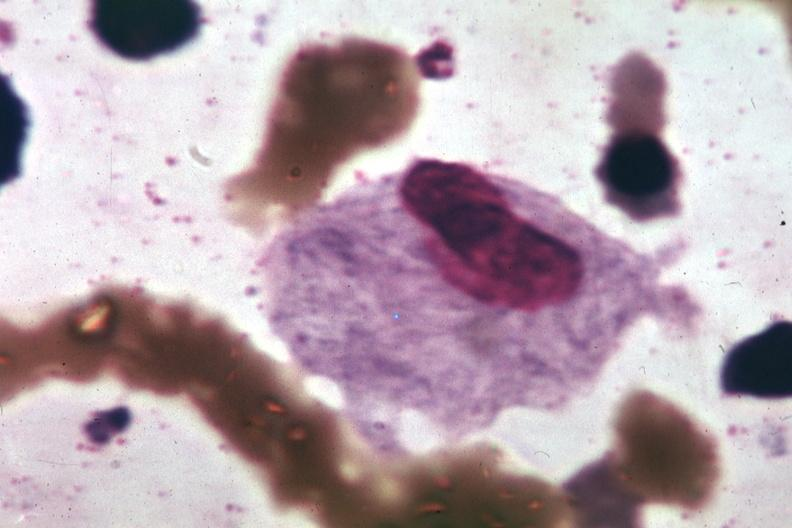does bilobed show wrights typical cell?
Answer the question using a single word or phrase. No 